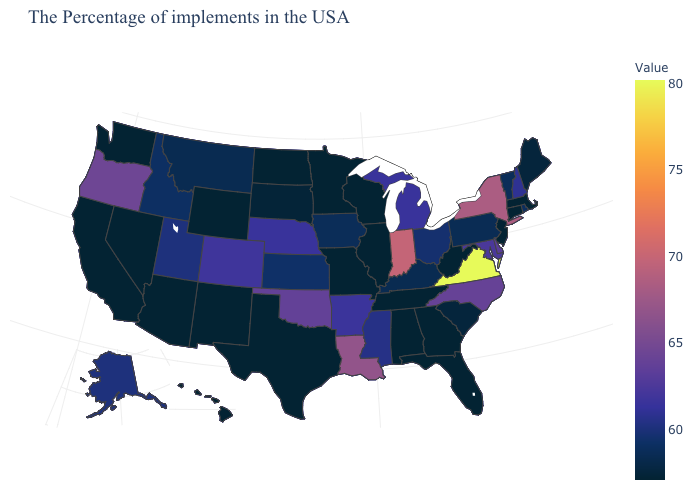Which states have the lowest value in the West?
Answer briefly. Wyoming, New Mexico, Arizona, Nevada, California, Washington, Hawaii. Among the states that border Mississippi , which have the highest value?
Quick response, please. Louisiana. Does Hawaii have the lowest value in the West?
Answer briefly. Yes. Does Wisconsin have the lowest value in the USA?
Quick response, please. Yes. Is the legend a continuous bar?
Keep it brief. Yes. Which states have the lowest value in the MidWest?
Give a very brief answer. Wisconsin, Illinois, Missouri, Minnesota, North Dakota. 